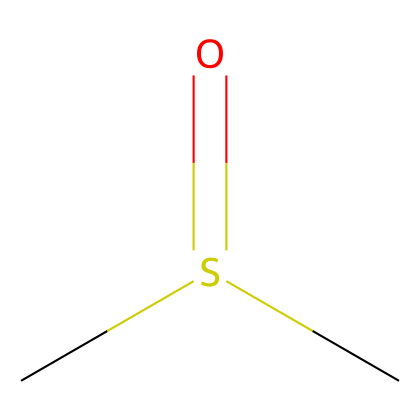What is the molecular formula of DMSO? The SMILES notation indicates two carbon atoms (C), one sulfur atom (S), and one oxygen atom (O), leading to the molecular formula C2H6OS.
Answer: C2H6OS How many carbon atoms are present in dimethyl sulfoxide? Observing the SMILES, there are two "C" symbols representing two carbon atoms in the structure.
Answer: 2 What functional group is present in DMSO? The SMILES shows a sulfur atom bonded to an oxygen atom via a double bond (S=O), indicating the presence of a sulfoxide functional group.
Answer: sulfoxide What is the total number of hydrogen atoms bonded to this molecule? The two carbon atoms each bond with three hydrogen atoms, making a total of 6 hydrogen atoms; therefore, the count from the structure combined leads to 6.
Answer: 6 Is DMSO polar or nonpolar? The presence of the polar sulfoxide group (S=O) in the molecular structure indicates that the molecule is polar due to its ability to interact with water and other polar solvents.
Answer: polar How does DMSO affect neural cell membranes? DMSO is a known solvent that can permeabilize cell membranes, possibly enhancing the uptake of substances into neural cells due to its polarity and ability to dissolve various chemicals.
Answer: permeabilize What type of compound is dimethyl sulfoxide categorized as? Based on its structure containing sulfur, dimethyl sulfoxide is categorized as a sulfur compound, particularly an organosulfur compound.
Answer: organosulfur compound 